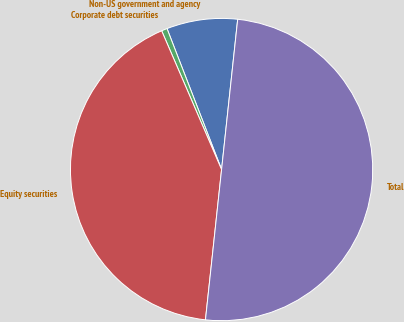<chart> <loc_0><loc_0><loc_500><loc_500><pie_chart><fcel>Non-US government and agency<fcel>Corporate debt securities<fcel>Equity securities<fcel>Total<nl><fcel>7.58%<fcel>0.61%<fcel>41.81%<fcel>50.0%<nl></chart> 